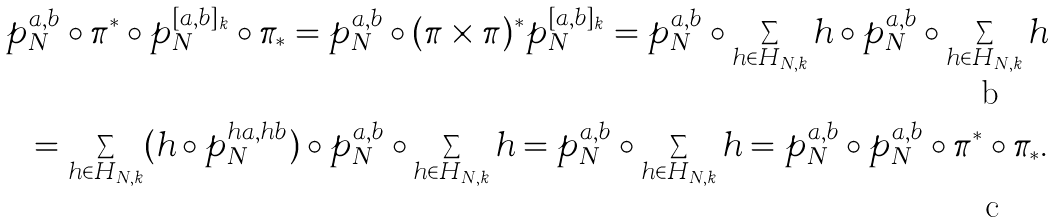<formula> <loc_0><loc_0><loc_500><loc_500>p _ { N } ^ { a , b } \circ \pi ^ { * } \circ p _ { N } ^ { [ a , b ] _ { k } } \circ \pi _ { * } = p _ { N } ^ { a , b } \circ ( \pi \times \pi ) ^ { * } p _ { N } ^ { [ a , b ] _ { k } } = p _ { N } ^ { a , b } \circ \sum _ { h \in H _ { N , k } } h \circ p _ { N } ^ { a , b } \circ \sum _ { h \in H _ { N , k } } h \\ = \sum _ { h \in H _ { N , k } } ( h \circ p _ { N } ^ { h a , h b } ) \circ p _ { N } ^ { a , b } \circ \sum _ { h \in H _ { N , k } } h = p _ { N } ^ { a , b } \circ \sum _ { h \in H _ { N , k } } h = p _ { N } ^ { a , b } \circ p _ { N } ^ { a , b } \circ \pi ^ { * } \circ \pi _ { * } .</formula> 